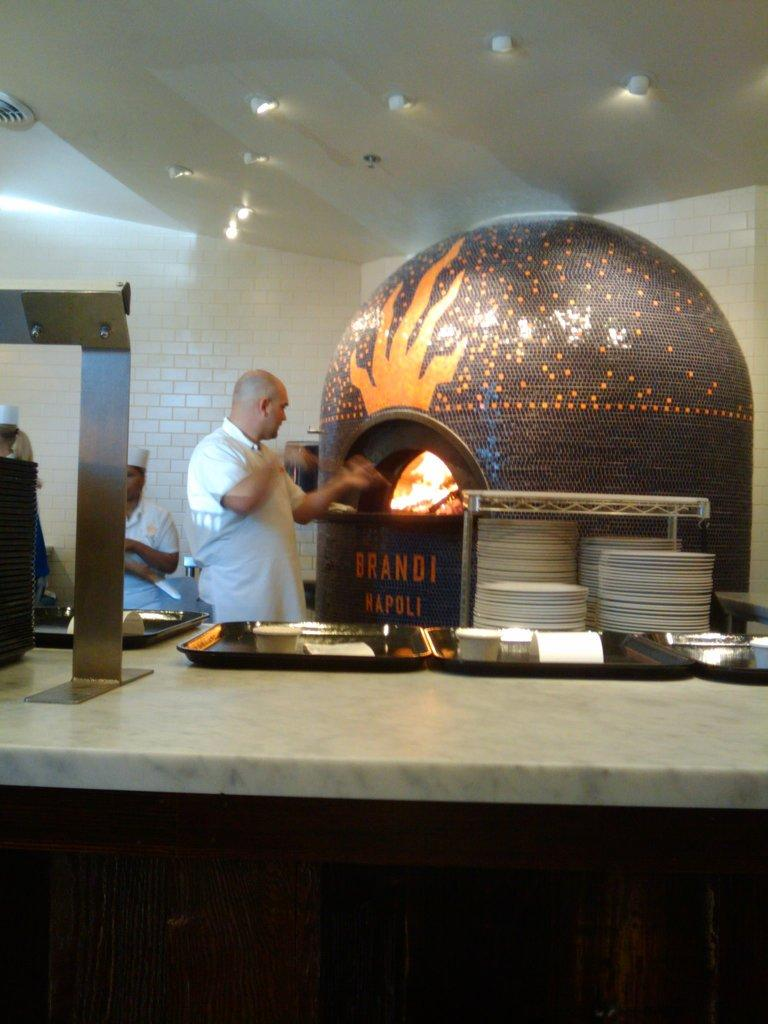<image>
Create a compact narrative representing the image presented. A man takes something out of an oven with the name Brandi Napoli on it. 